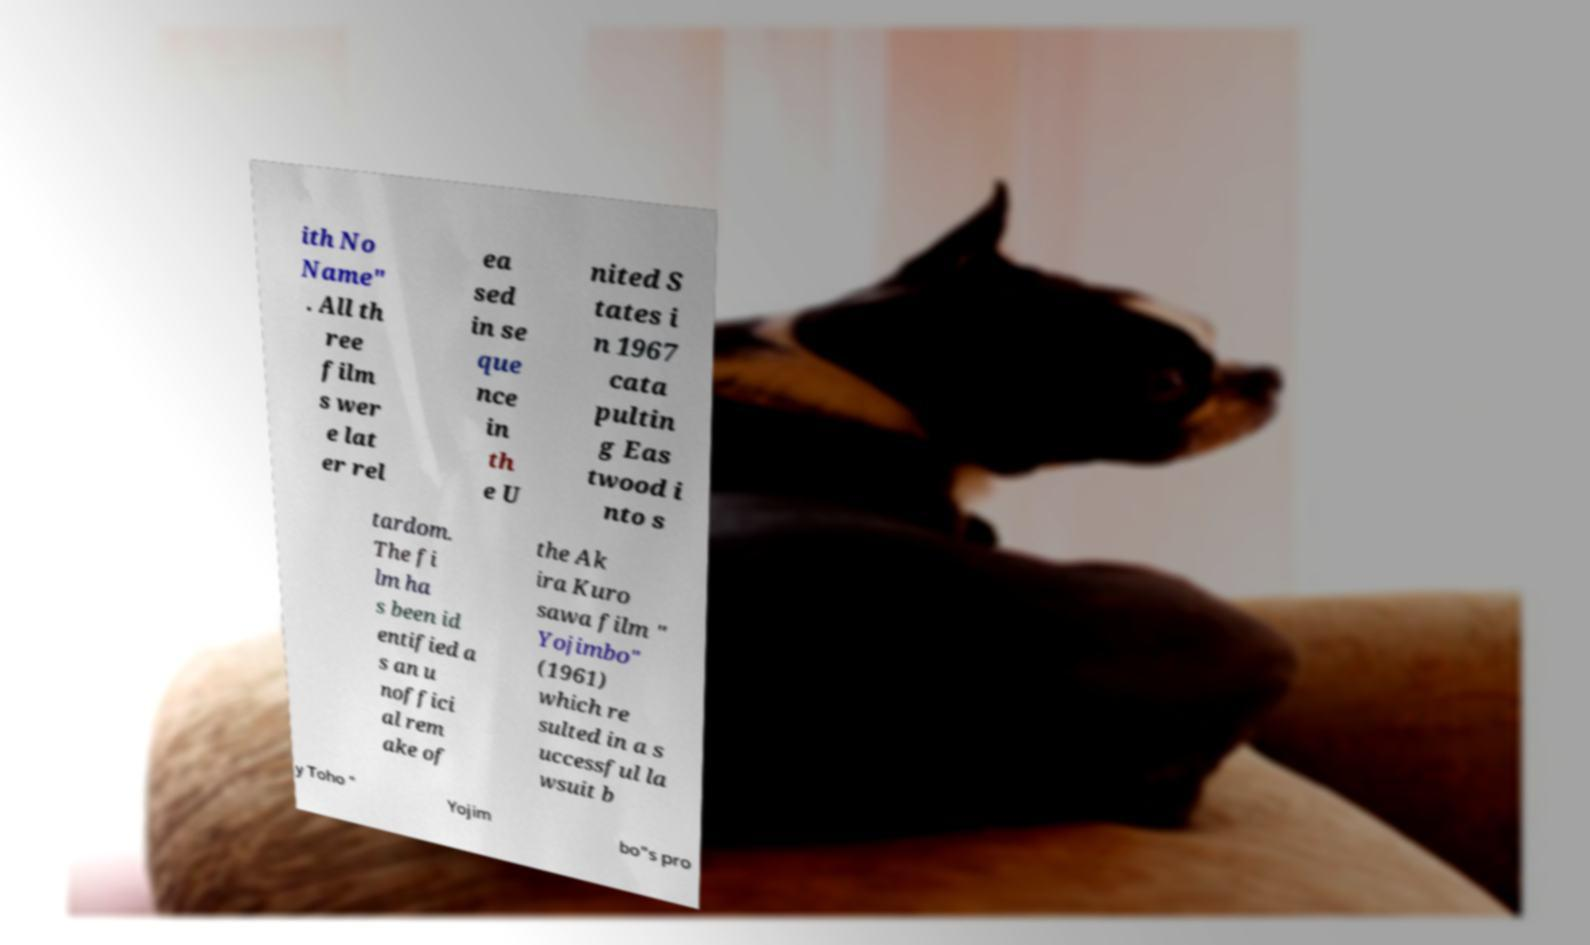Could you extract and type out the text from this image? ith No Name" . All th ree film s wer e lat er rel ea sed in se que nce in th e U nited S tates i n 1967 cata pultin g Eas twood i nto s tardom. The fi lm ha s been id entified a s an u noffici al rem ake of the Ak ira Kuro sawa film " Yojimbo" (1961) which re sulted in a s uccessful la wsuit b y Toho " Yojim bo"s pro 